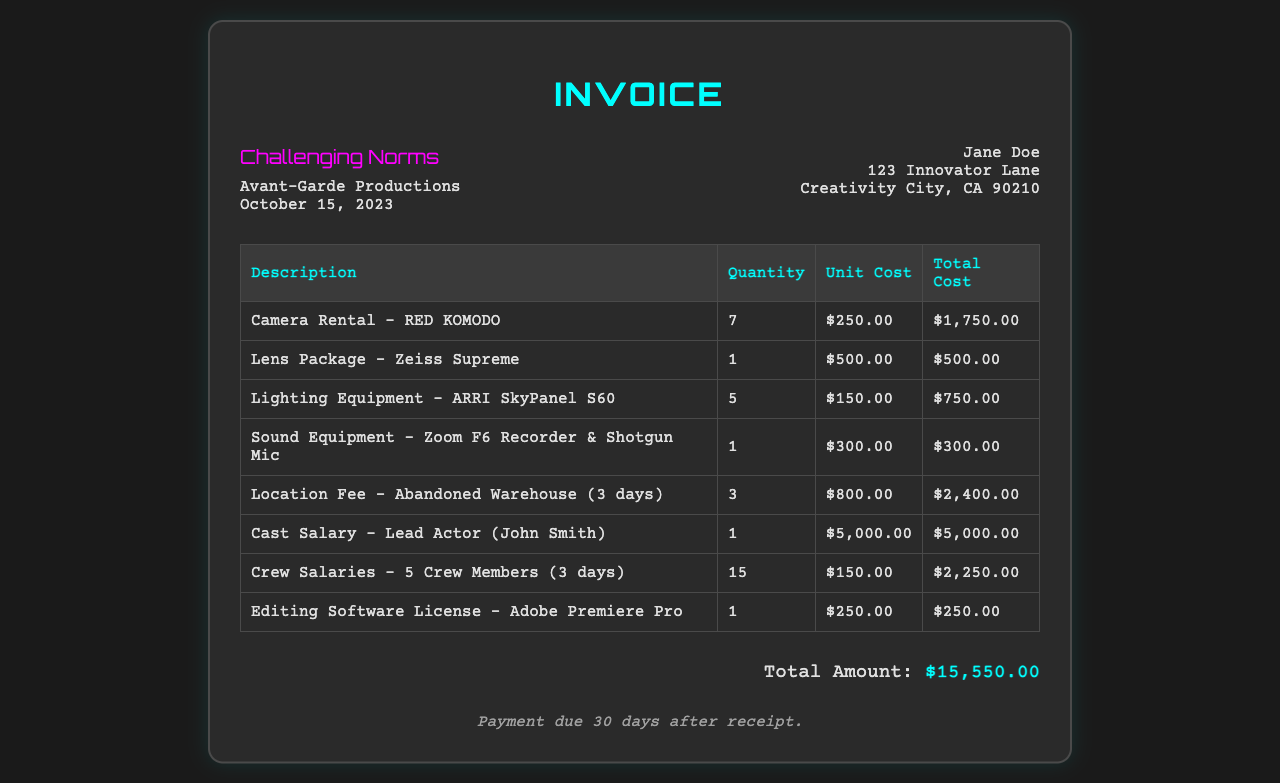what is the total amount? The total amount is listed at the bottom of the invoice, summarizing all costs incurred.
Answer: $15,550.00 who is the lead actor? The document specifies the name of the lead actor directly under the cast salary section.
Answer: John Smith how many crew members are accounted for? The document states that there are a total of five crew members for the production.
Answer: 5 what is the lens package used? The description of the lens package is provided in the equipment section of the invoice.
Answer: Zeiss Supreme what is the payment due period? The payment terms clearly indicate how long after receipt payment is due.
Answer: 30 days how many days was the location fee charged for? The invoice details how many days the location was rented for under the location fee entry.
Answer: 3 days what is the cost of the camera rental? The cost for camera rental can be found in the equipment rental section for clarity.
Answer: $1,750.00 what is the name of the company? The company's name is prominently displayed at the top of the invoice.
Answer: Avant-Garde Productions 